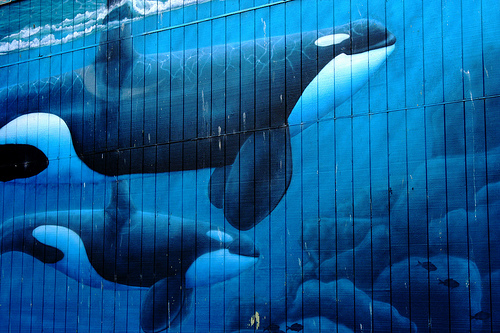<image>
Is the whale next to the orca? Yes. The whale is positioned adjacent to the orca, located nearby in the same general area. Is the fish next to the orca? No. The fish is not positioned next to the orca. They are located in different areas of the scene. 